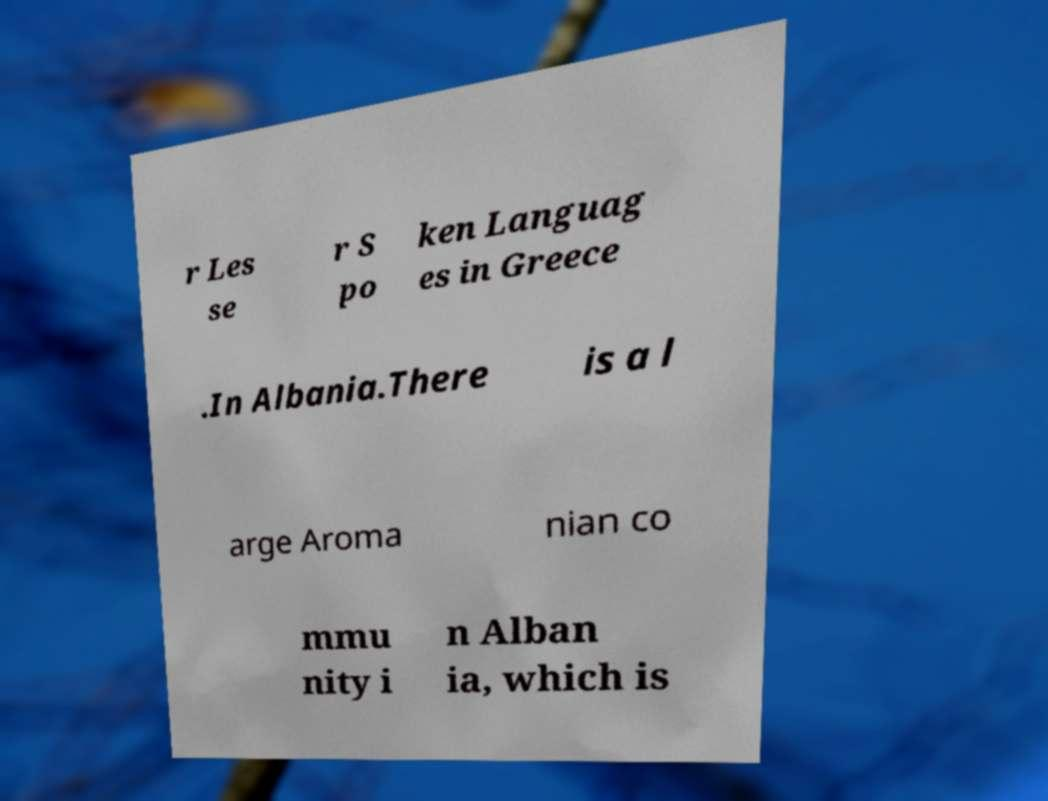Please read and relay the text visible in this image. What does it say? r Les se r S po ken Languag es in Greece .In Albania.There is a l arge Aroma nian co mmu nity i n Alban ia, which is 